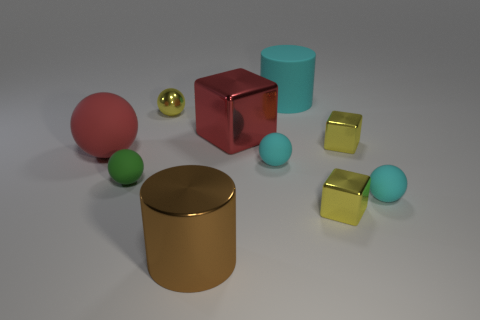What number of objects are either tiny cyan rubber objects that are to the right of the large cyan thing or big green rubber blocks?
Your answer should be compact. 1. There is a big thing that is the same color as the big ball; what shape is it?
Your response must be concise. Cube. The large object on the left side of the cylinder to the left of the red metal cube is made of what material?
Provide a short and direct response. Rubber. Are there any large cylinders that have the same material as the big red sphere?
Make the answer very short. Yes. Are there any cyan objects left of the rubber object behind the yellow sphere?
Your answer should be very brief. Yes. There is a large object left of the large brown metal object; what is its material?
Your answer should be very brief. Rubber. Is the small green matte thing the same shape as the red matte thing?
Give a very brief answer. Yes. The matte object that is on the right side of the yellow object that is in front of the red thing to the left of the red cube is what color?
Provide a short and direct response. Cyan. How many big brown shiny objects are the same shape as the big cyan matte thing?
Give a very brief answer. 1. There is a cyan rubber object to the left of the cylinder right of the brown cylinder; how big is it?
Offer a terse response. Small. 